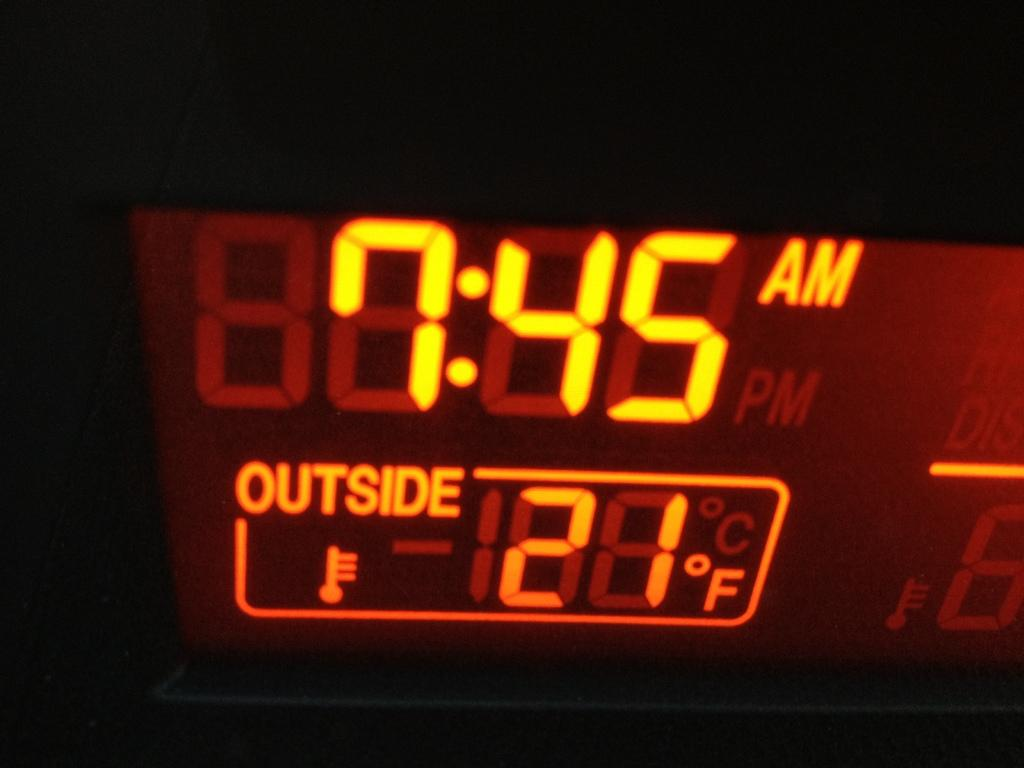<image>
Give a short and clear explanation of the subsequent image. an alarm that has the time of 7:45 on it 